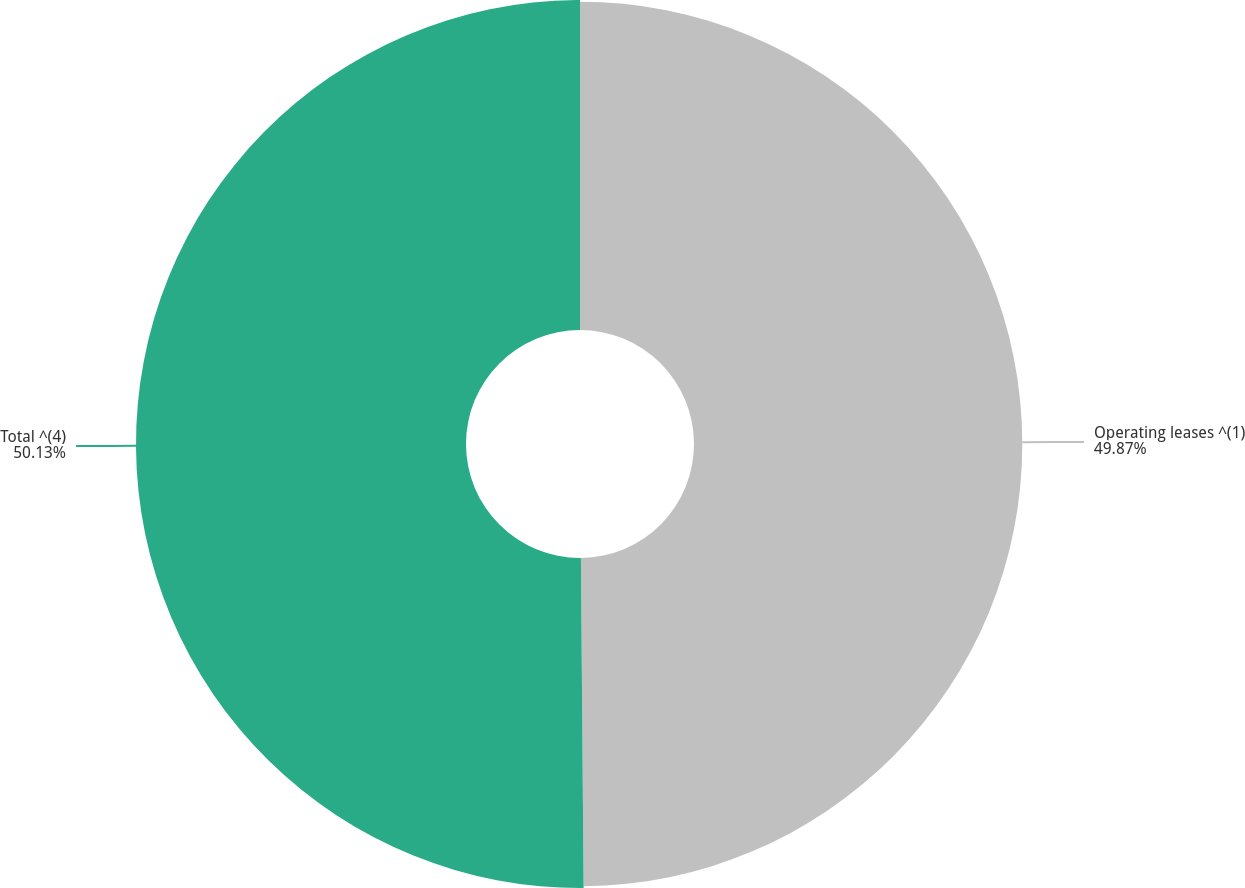<chart> <loc_0><loc_0><loc_500><loc_500><pie_chart><fcel>Operating leases ^(1)<fcel>Total ^(4)<nl><fcel>49.87%<fcel>50.13%<nl></chart> 